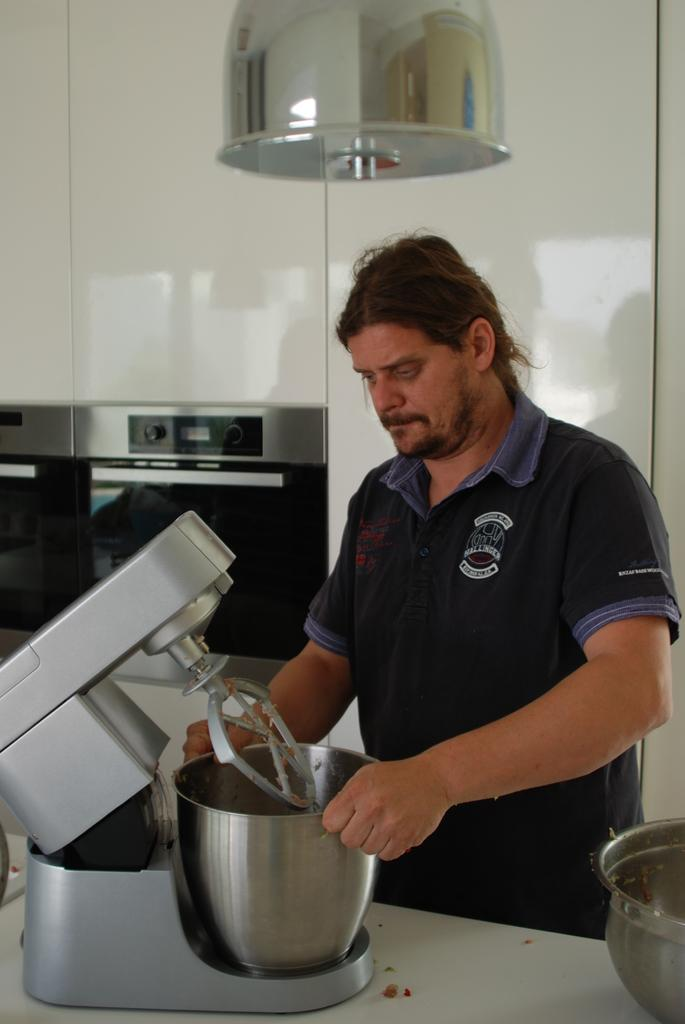Who is present in the image? There is a man in the image. What is the man holding in the image? The man is holding a mixing machine. Where is the mixing machine located in the image? The mixing machine is on a table. What else can be seen on the table in the image? There is a vessel on the table. What can be seen in the background of the image? There is a white wall in the background. What is present on the white wall in the image? There is an electronic item on the white wall. What type of song is the man playing on the instrument in the image? There is no instrument present in the image, and the man is not playing any song. 